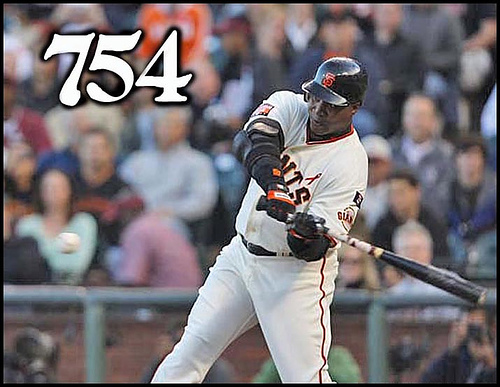Identify the text displayed in this image. 754 NTS n 